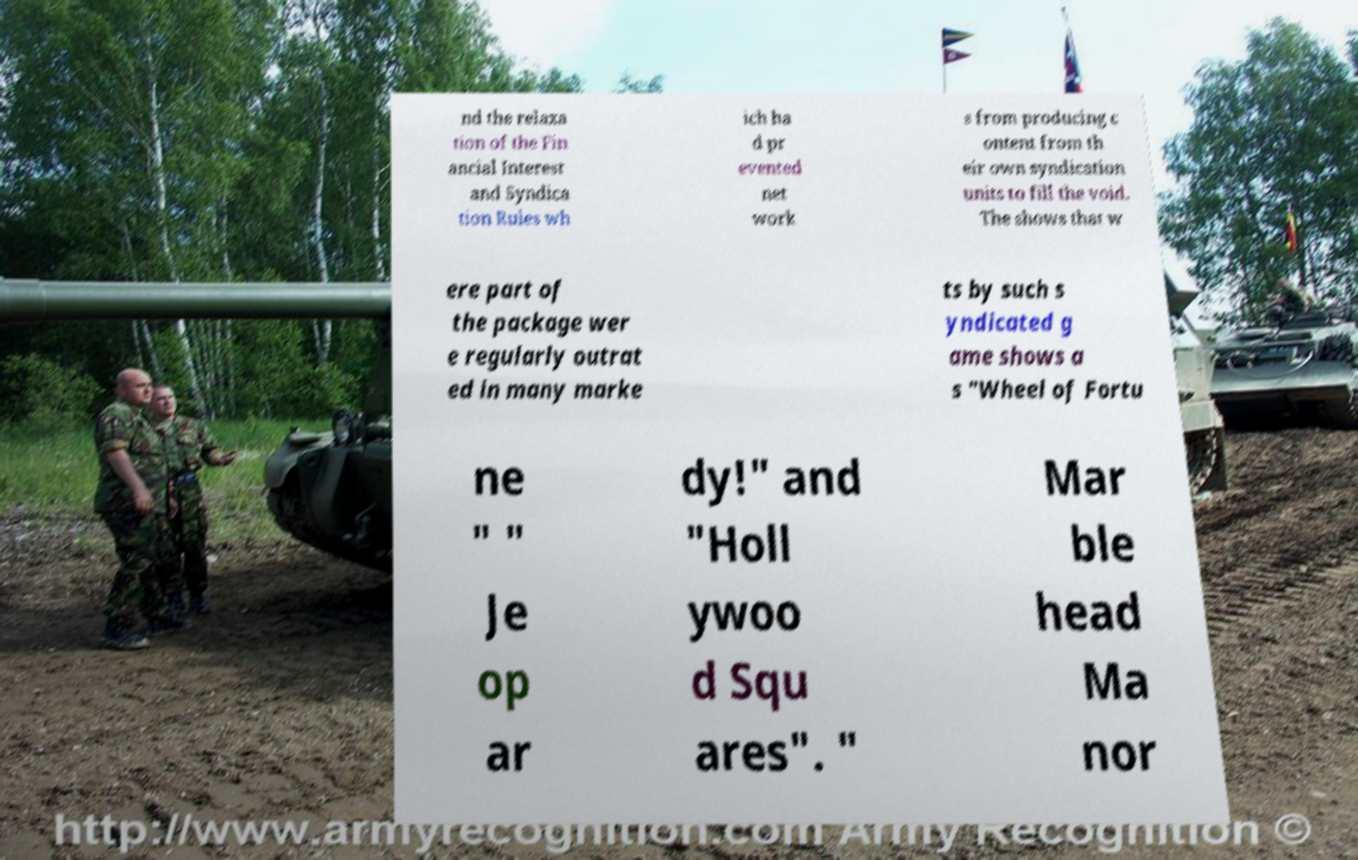What messages or text are displayed in this image? I need them in a readable, typed format. nd the relaxa tion of the Fin ancial Interest and Syndica tion Rules wh ich ha d pr evented net work s from producing c ontent from th eir own syndication units to fill the void. The shows that w ere part of the package wer e regularly outrat ed in many marke ts by such s yndicated g ame shows a s "Wheel of Fortu ne " " Je op ar dy!" and "Holl ywoo d Squ ares". " Mar ble head Ma nor 